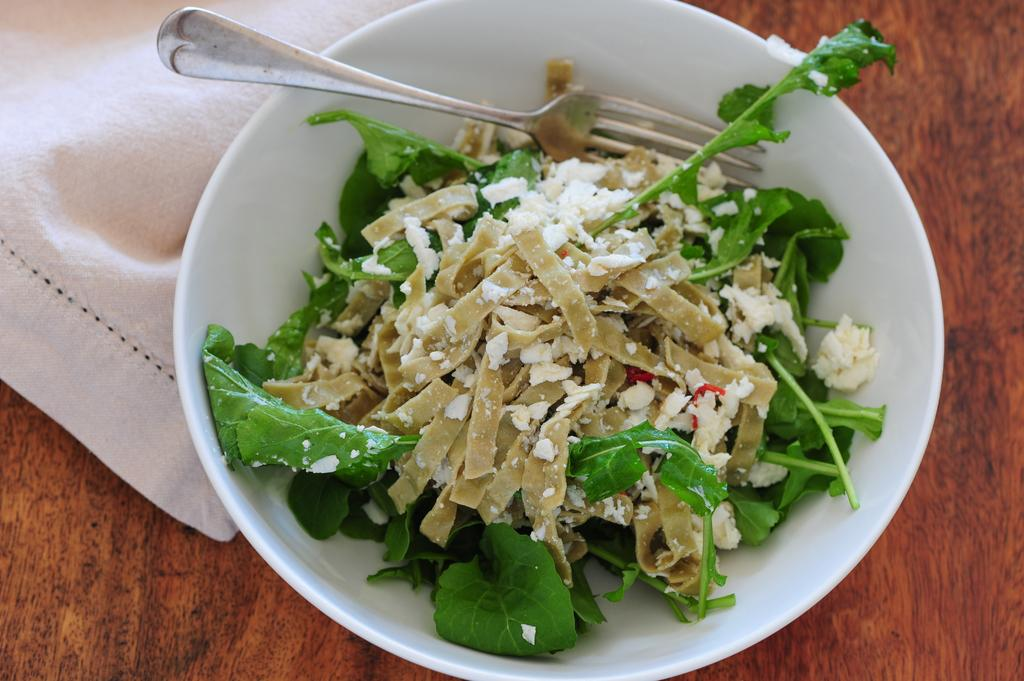What is located in the center of the image? There is a table in the center of the image. What is covering the table? There is a cloth on the table. What is placed on top of the cloth? There is a bowl on the table. What utensil can be seen in the bowl? There is a fork in the bowl. What is inside the bowl with the fork and the utensil? There is a food item in the bowl. Can you tell me how many turkeys are on the table in the image? There are no turkeys present in the image. Are there any dinosaurs visible in the image? There are no dinosaurs present in the image. 